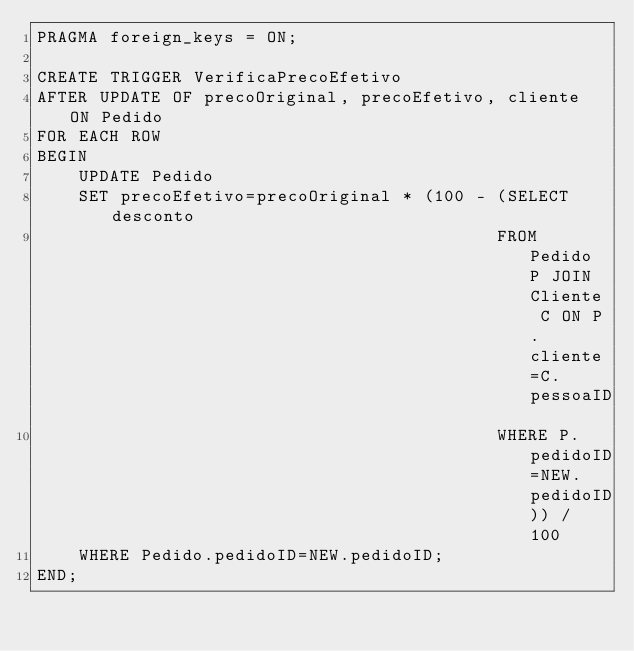<code> <loc_0><loc_0><loc_500><loc_500><_SQL_>PRAGMA foreign_keys = ON;

CREATE TRIGGER VerificaPrecoEfetivo
AFTER UPDATE OF precoOriginal, precoEfetivo, cliente ON Pedido
FOR EACH ROW
BEGIN
    UPDATE Pedido
    SET precoEfetivo=precoOriginal * (100 - (SELECT desconto
                                            FROM Pedido P JOIN Cliente C ON P.cliente=C.pessoaID
                                            WHERE P.pedidoID=NEW.pedidoID)) / 100
    WHERE Pedido.pedidoID=NEW.pedidoID;
END;</code> 